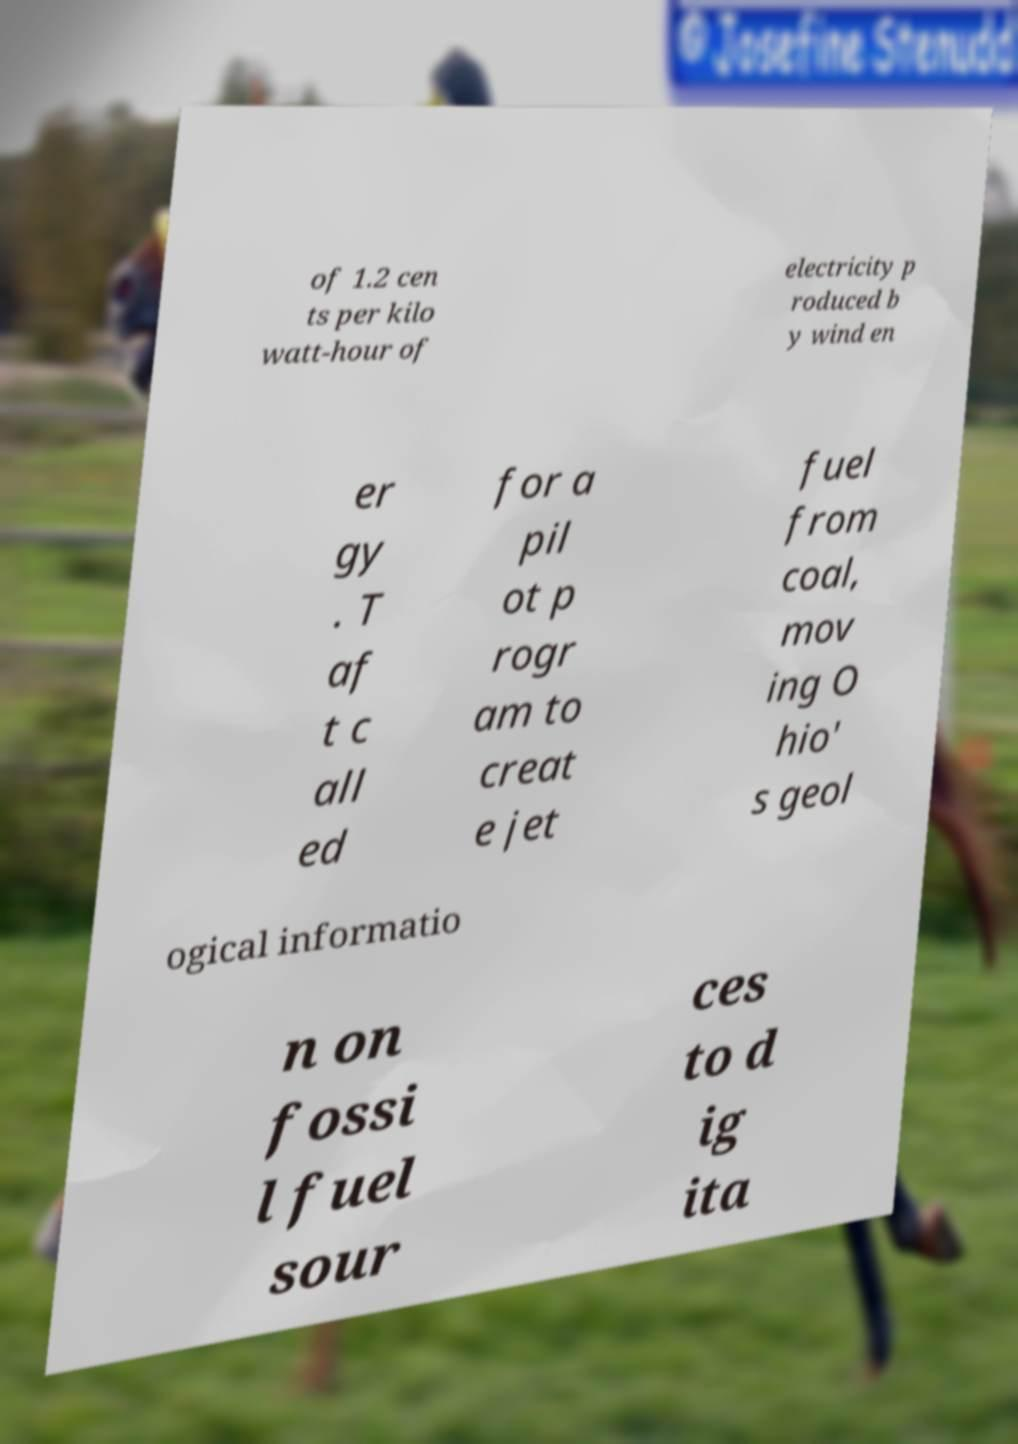Please identify and transcribe the text found in this image. of 1.2 cen ts per kilo watt-hour of electricity p roduced b y wind en er gy . T af t c all ed for a pil ot p rogr am to creat e jet fuel from coal, mov ing O hio' s geol ogical informatio n on fossi l fuel sour ces to d ig ita 